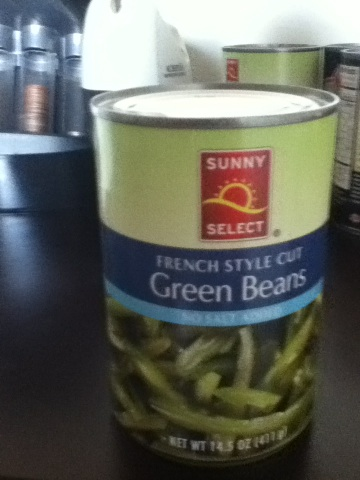What is this? from Vizwiz green beans 